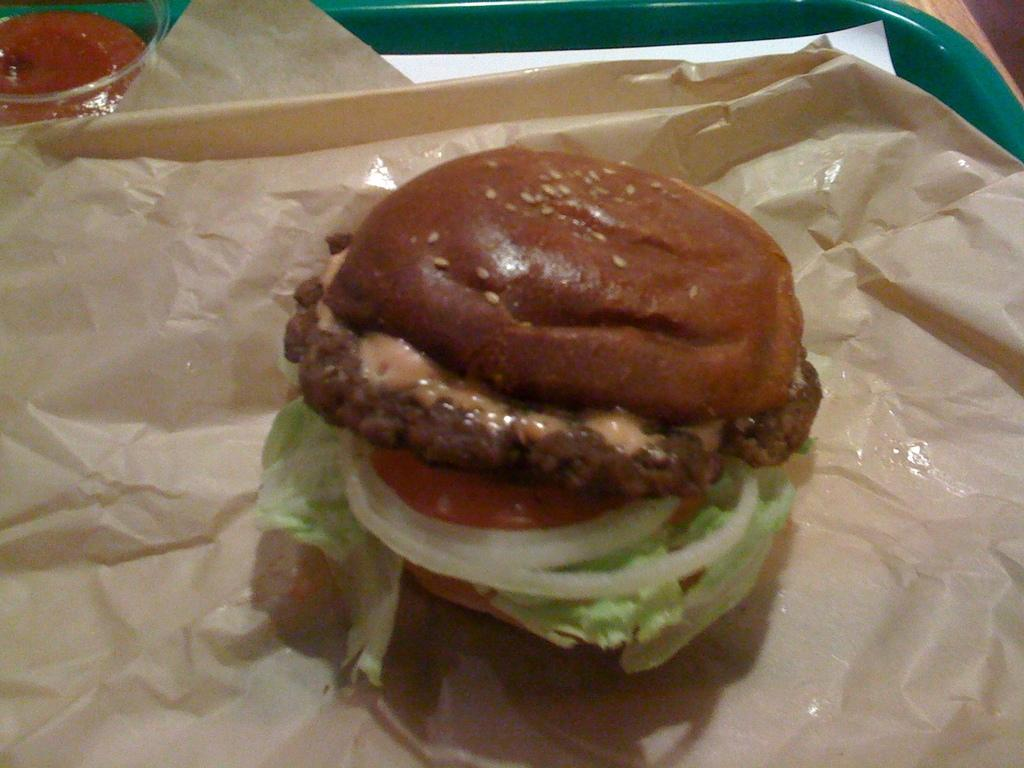What type of food is the main subject of the picture? There is a burger in the picture. What ingredients can be seen on the burger? The burger has onions, tomatoes, cabbage, and sesame seeds. How is the burger presented in the image? The burger is placed on a wrapper and a tray. What type of clouds can be seen in the picture? There are no clouds visible in the picture; it features a burger with various ingredients. Can you tell me how many cubs are present in the image? There are no cubs present in the image; it features a burger with various ingredients. 